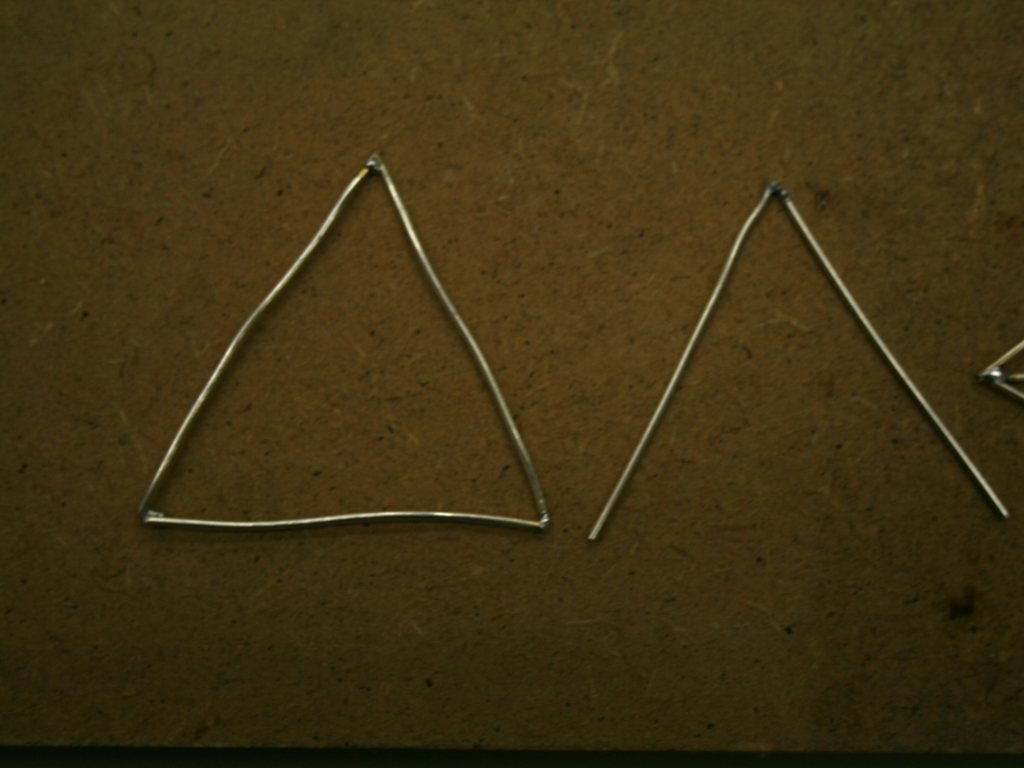What materials are the objects in the image made of? The objects appear to be made of a slender, metallic wire or rod bent into triangular shapes. The material has a luster that suggests it could be a type of metal. 